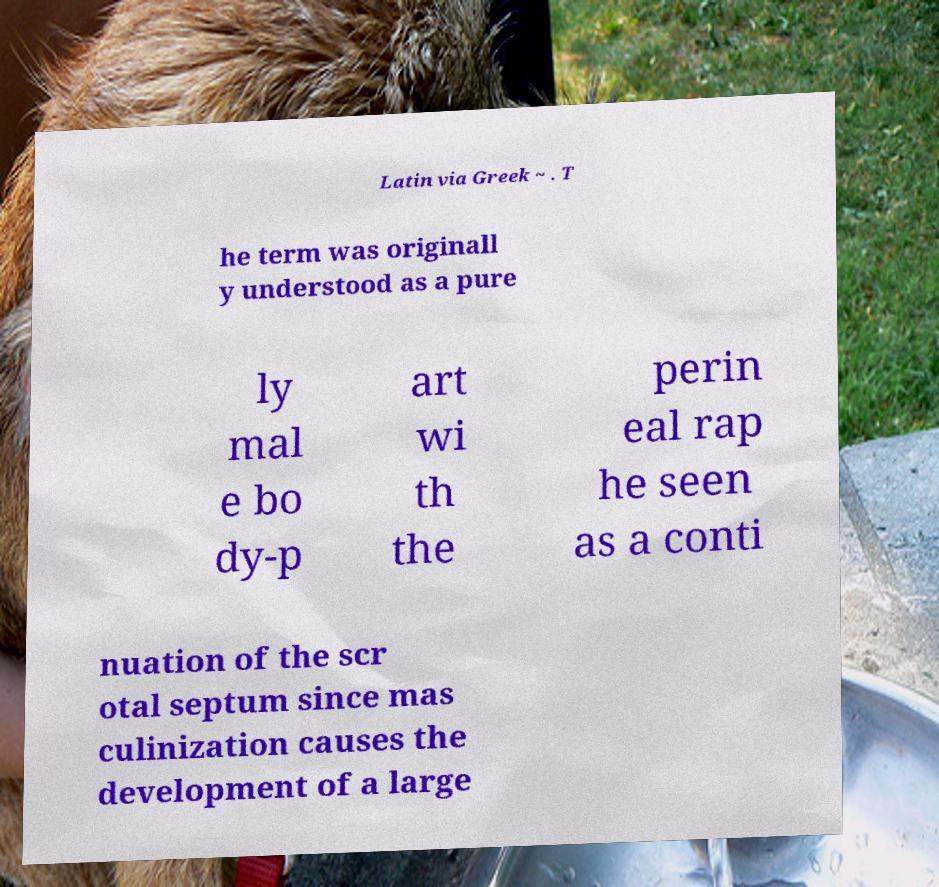Could you assist in decoding the text presented in this image and type it out clearly? Latin via Greek ~ . T he term was originall y understood as a pure ly mal e bo dy-p art wi th the perin eal rap he seen as a conti nuation of the scr otal septum since mas culinization causes the development of a large 